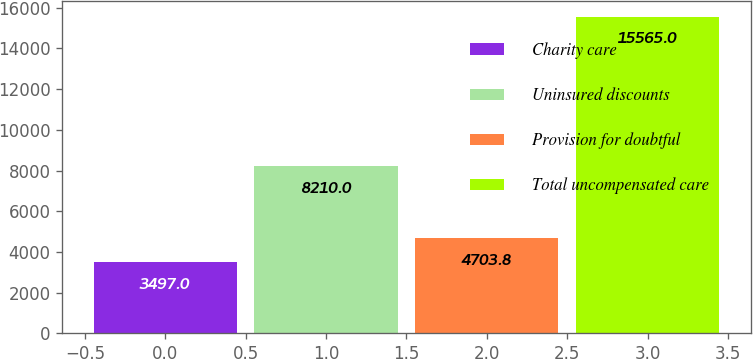Convert chart to OTSL. <chart><loc_0><loc_0><loc_500><loc_500><bar_chart><fcel>Charity care<fcel>Uninsured discounts<fcel>Provision for doubtful<fcel>Total uncompensated care<nl><fcel>3497<fcel>8210<fcel>4703.8<fcel>15565<nl></chart> 